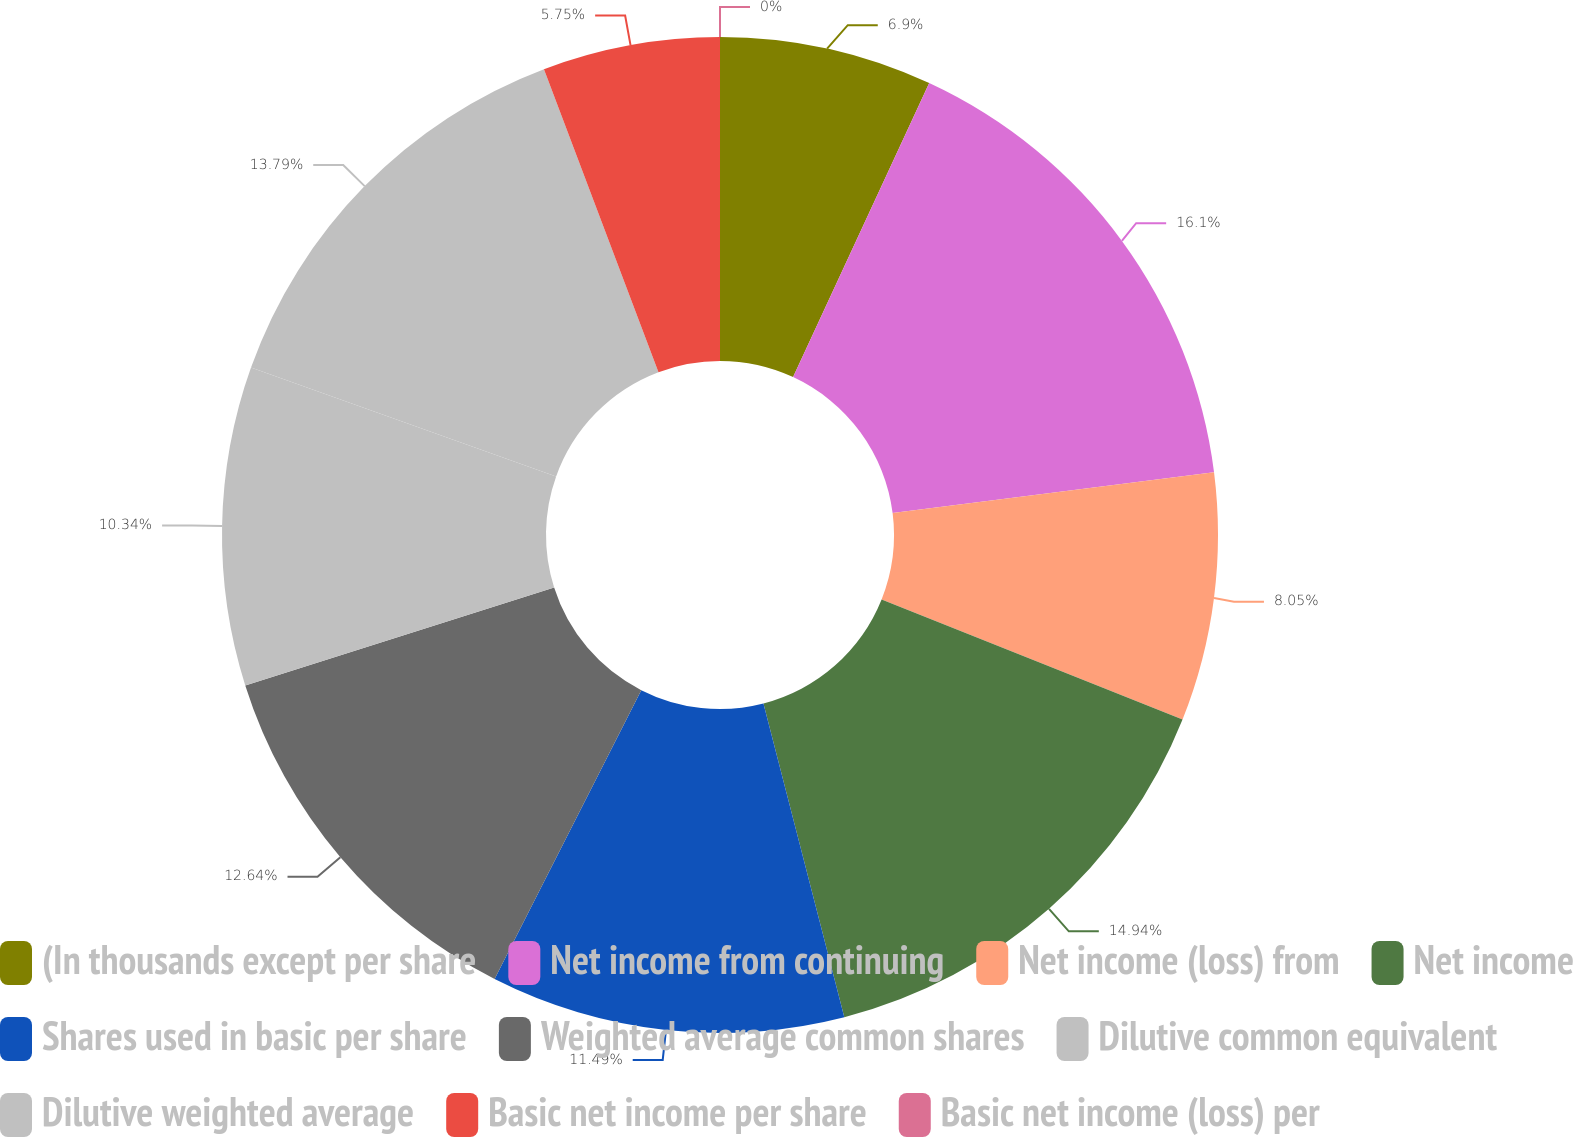Convert chart to OTSL. <chart><loc_0><loc_0><loc_500><loc_500><pie_chart><fcel>(In thousands except per share<fcel>Net income from continuing<fcel>Net income (loss) from<fcel>Net income<fcel>Shares used in basic per share<fcel>Weighted average common shares<fcel>Dilutive common equivalent<fcel>Dilutive weighted average<fcel>Basic net income per share<fcel>Basic net income (loss) per<nl><fcel>6.9%<fcel>16.09%<fcel>8.05%<fcel>14.94%<fcel>11.49%<fcel>12.64%<fcel>10.34%<fcel>13.79%<fcel>5.75%<fcel>0.0%<nl></chart> 